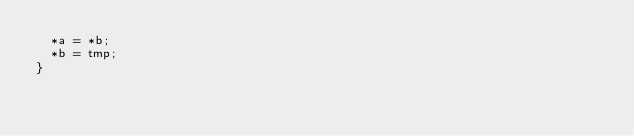<code> <loc_0><loc_0><loc_500><loc_500><_C_>  *a = *b;
  *b = tmp;
}
</code> 